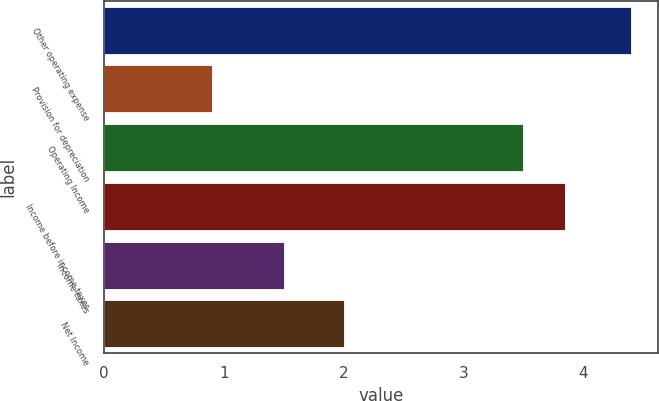Convert chart to OTSL. <chart><loc_0><loc_0><loc_500><loc_500><bar_chart><fcel>Other operating expense<fcel>Provision for depreciation<fcel>Operating Income<fcel>Income before income taxes<fcel>Income taxes<fcel>Net Income<nl><fcel>4.4<fcel>0.9<fcel>3.5<fcel>3.85<fcel>1.5<fcel>2<nl></chart> 